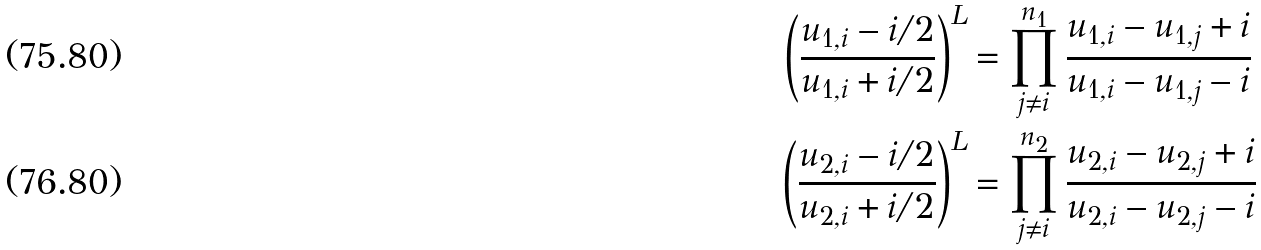<formula> <loc_0><loc_0><loc_500><loc_500>\left ( \frac { u _ { 1 , i } - i / 2 } { u _ { 1 , i } + i / 2 } \right ) ^ { L } & = \prod _ { j \neq i } ^ { n _ { 1 } } \frac { u _ { 1 , i } - u _ { 1 , j } + i } { u _ { 1 , i } - u _ { 1 , j } - i } \\ \left ( \frac { u _ { 2 , i } - i / 2 } { u _ { 2 , i } + i / 2 } \right ) ^ { L } & = \prod _ { j \neq i } ^ { n _ { 2 } } \frac { u _ { 2 , i } - u _ { 2 , j } + i } { u _ { 2 , i } - u _ { 2 , j } - i }</formula> 